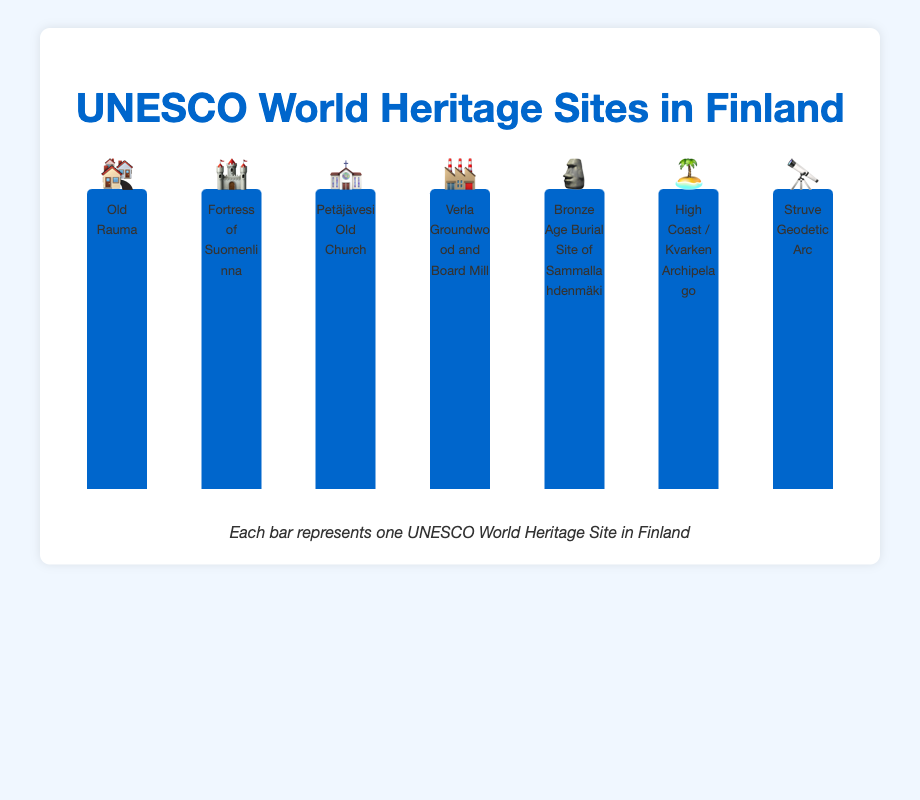What is the title of the chart? The title is displayed at the top center of the chart. It helps quickly understand what the chart is about.
Answer: UNESCO World Heritage Sites in Finland Which type of site is more common, Cultural or Natural? The chart shows that there are six bars with cultural emojis and only one bar with a natural emoji.
Answer: Cultural How many UNESCO World Heritage Sites are there in Finland? Count the total number of bars in the chart. Each bar represents one UNESCO World Heritage Site.
Answer: 7 What historical site is represented by the emoji 🏘️? The emoji 🏘️ is positioned above the label that indicates the site name.
Answer: Old Rauma How many sites are represented by cultural emojis? The bars labeled 🏘️, 🏰, ⛪, 🏭, 🗿, and 🔭 are all classified under cultural sites.
Answer: 6 Which site represents the only natural heritage site? Look for the bar with a different emoji compared to the other cultural ones.
Answer: High Coast / Kvarken Archipelago Which emoji represents the Bronze Age Burial Site of Sammallahdenmäki? Identify the label for "Bronze Age Burial Site of Sammallahdenmäki" and see the emoji above it.
Answer: 🗿 Are there any bars representing more than one site? Observe the labels and see if any label states more than one site.
Answer: No What does the emoji 🔭 stand for? Find the label directly below the emoji 🔭 which will reveal the site name.
Answer: Struve Geodetic Arc 